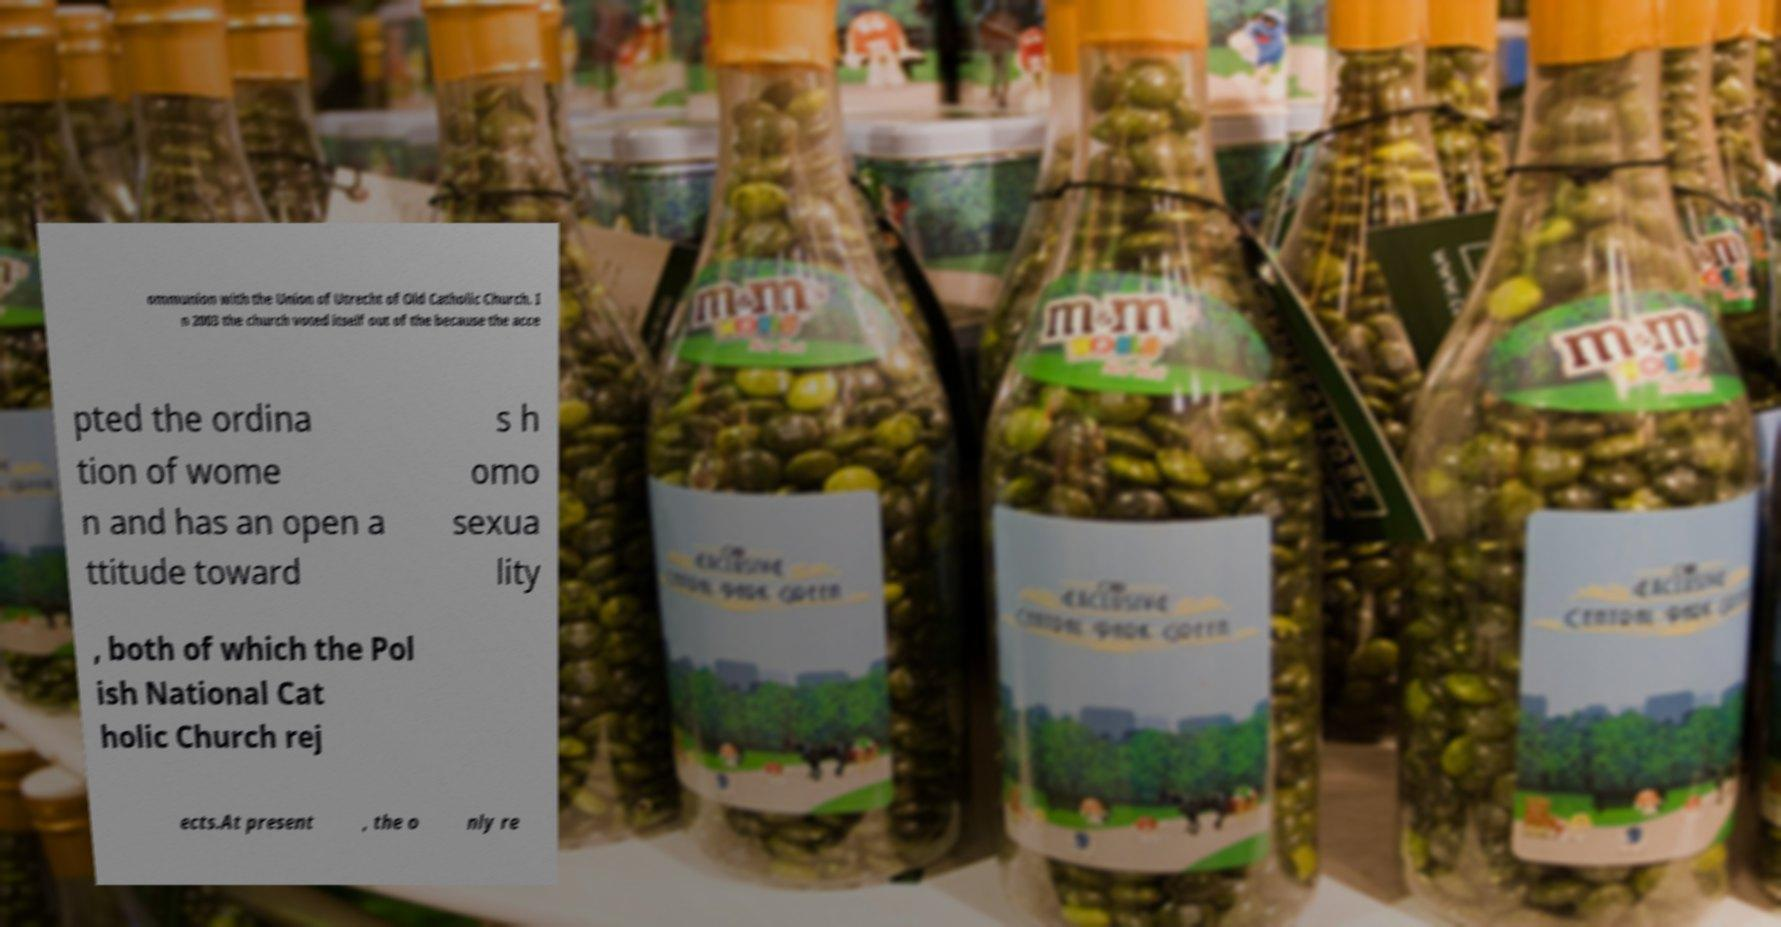For documentation purposes, I need the text within this image transcribed. Could you provide that? ommunion with the Union of Utrecht of Old Catholic Church. I n 2003 the church voted itself out of the because the acce pted the ordina tion of wome n and has an open a ttitude toward s h omo sexua lity , both of which the Pol ish National Cat holic Church rej ects.At present , the o nly re 